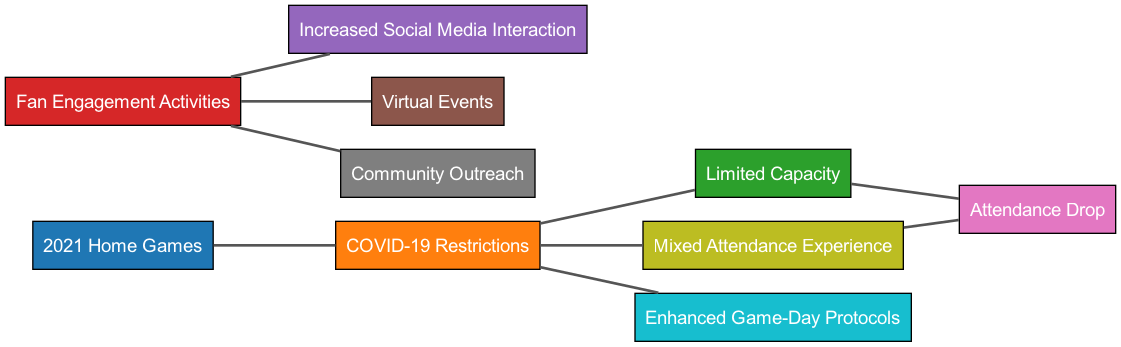What is the total number of nodes in the diagram? The diagram consists of 10 distinct nodes, including "2021 Home Games", "COVID-19 Restrictions", "Limited Capacity", "Fan Engagement Activities", "Increased Social Media Interaction", "Virtual Events", "Attendance Drop", "Community Outreach", "Mixed Attendance Experience", and "Enhanced Game-Day Protocols".
Answer: 10 What is the main outcome of the "COVID-19 Restrictions" node? The "COVID-19 Restrictions" node connects to four other nodes: "Limited Capacity", "Enhanced Game-Day Protocols", "Mixed Attendance Experience", and ultimately leads to a drop in attendance. Therefore, these four nodes represent the key outcomes related to the restrictions.
Answer: Limited Capacity, Enhanced Game-Day Protocols, Mixed Attendance Experience Which node is directly linked to "Fan Engagement Activities"? The "Fan Engagement Activities" node has three direct connections: "Increased Social Media Interaction", "Virtual Events", and "Community Outreach". These nodes illustrate the various activities that were introduced to engage fans.
Answer: Increased Social Media Interaction, Virtual Events, Community Outreach How many edges originate from the "Limited Capacity" node? The "Limited Capacity" node has one outgoing edge that leads to the "Attendance Drop" node, indicating that the limitation in capacity has a direct effect on attendance figures.
Answer: 1 What is the relationship between "Mixed Attendance Experience" and "Attendance Drop"? The "Mixed Attendance Experience" node has a direct link to the "Attendance Drop" node, implying that variations in how fans experienced the games had a negative effect on overall attendance, contributing to a drop.
Answer: Attendance Drop How do fan engagement activities correlate with attendance? Fan engagement activities lead to three outcomes: "Increased Social Media Interaction", "Virtual Events", and "Community Outreach", which can help maintain or increase attendance despite restrictions. Therefore, they can positively correlate with attendance figures.
Answer: Positive correlation What is the impact of "COVID-19 Restrictions" on the overall attendance experience? The "COVID-19 Restrictions" node connects to "Limited Capacity", "Enhanced Game-Day Protocols", and "Mixed Attendance Experience". This suggests that the restrictions significantly altered the game-day experience, potentially influencing overall attendance negatively.
Answer: Altered attendance experience How can the effects of "Attendance Drop" be traced back through the diagram? The "Attendance Drop" can be traced back to the "Limited Capacity" node and the "Mixed Attendance Experience" node. By analyzing how these two nodes are influenced by "COVID-19 Restrictions", one can see the flow showing how restrictions ultimately impact attendance.
Answer: Through Limited Capacity and Mixed Attendance Experience 